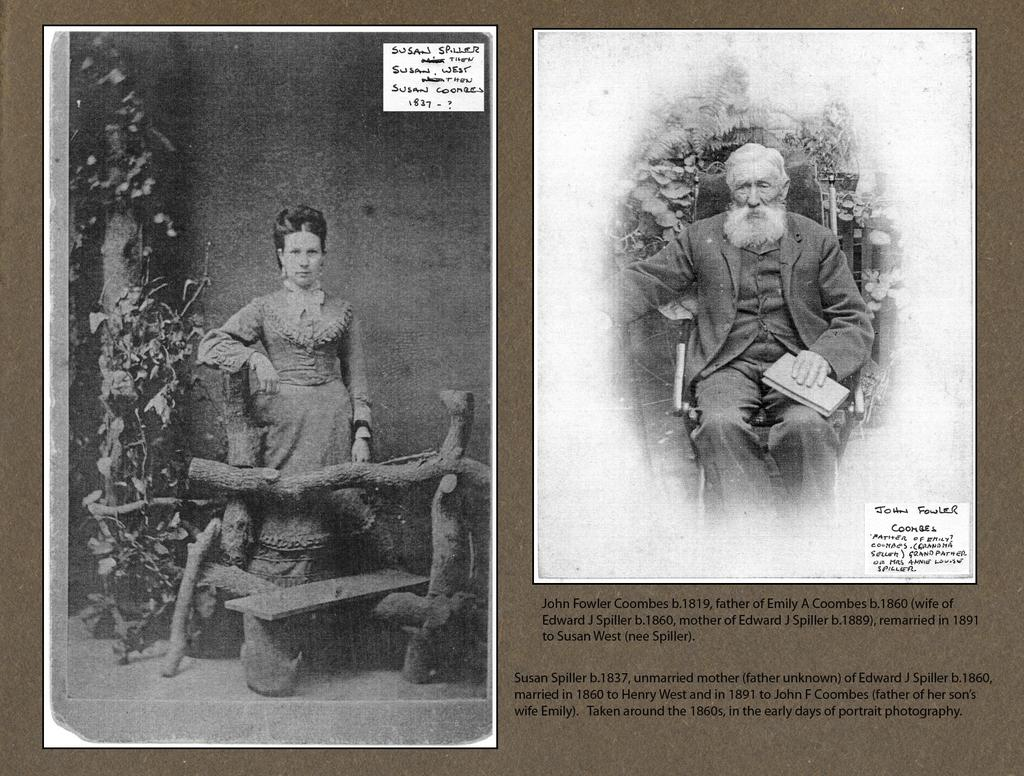What is present in the image that features images and text? There is a poster in the image. What type of content is displayed on the poster? The poster contains photos of two people. What else can be found on the poster besides the images? There is writing on the poster. What color is the hat worn by the person on the left side of the poster? There is no hat present on the poster, as the provided facts only mention photos of two people and writing on the poster. 